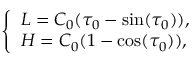Convert formula to latex. <formula><loc_0><loc_0><loc_500><loc_500>\left \{ { \begin{array} { l } { L = C _ { 0 } ( \tau _ { 0 } - \sin ( \tau _ { 0 } ) ) , } \\ { H = C _ { 0 } ( 1 - \cos ( \tau _ { 0 } ) ) , } \end{array} }</formula> 